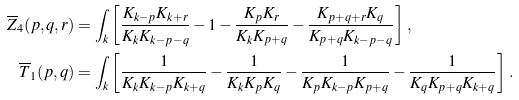<formula> <loc_0><loc_0><loc_500><loc_500>\overline { Z } _ { 4 } ( p , q , r ) & = \int _ { k } \left [ \frac { K _ { k - p } K _ { k + r } } { K _ { k } K _ { k - p - q } } - 1 - \frac { K _ { p } K _ { r } } { K _ { k } K _ { p + q } } - \frac { K _ { p + q + r } K _ { q } } { K _ { p + q } K _ { k - p - q } } \right ] \, , \\ \overline { T } _ { 1 } ( p , q ) & = \int _ { k } \left [ \frac { 1 } { K _ { k } K _ { k - p } K _ { k + q } } - \frac { 1 } { K _ { k } K _ { p } K _ { q } } - \frac { 1 } { K _ { p } K _ { k - p } K _ { p + q } } - \frac { 1 } { K _ { q } K _ { p + q } K _ { k + q } } \right ] \, .</formula> 